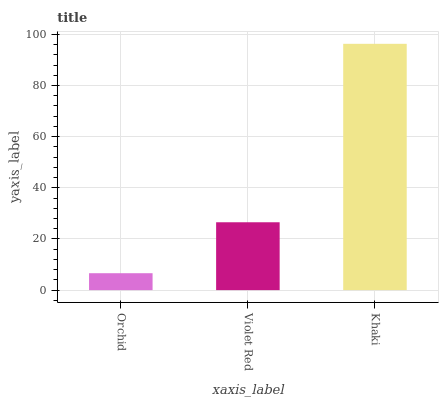Is Orchid the minimum?
Answer yes or no. Yes. Is Khaki the maximum?
Answer yes or no. Yes. Is Violet Red the minimum?
Answer yes or no. No. Is Violet Red the maximum?
Answer yes or no. No. Is Violet Red greater than Orchid?
Answer yes or no. Yes. Is Orchid less than Violet Red?
Answer yes or no. Yes. Is Orchid greater than Violet Red?
Answer yes or no. No. Is Violet Red less than Orchid?
Answer yes or no. No. Is Violet Red the high median?
Answer yes or no. Yes. Is Violet Red the low median?
Answer yes or no. Yes. Is Khaki the high median?
Answer yes or no. No. Is Orchid the low median?
Answer yes or no. No. 